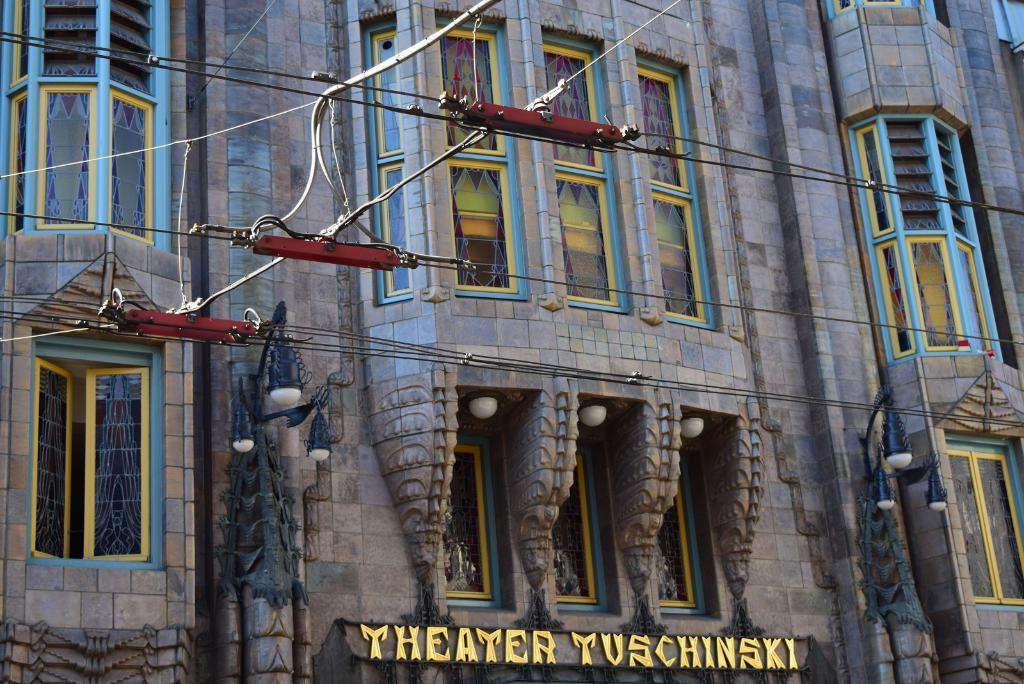What is the main subject of the image? The main subject of the image is the front view of a building. Are there any additional features visible in the image? Yes, electrical wires are present in the image. How many friends can be seen playing with the rock in the image? There are no friends or rocks present in the image; it only shows the front view of a building and electrical wires. 